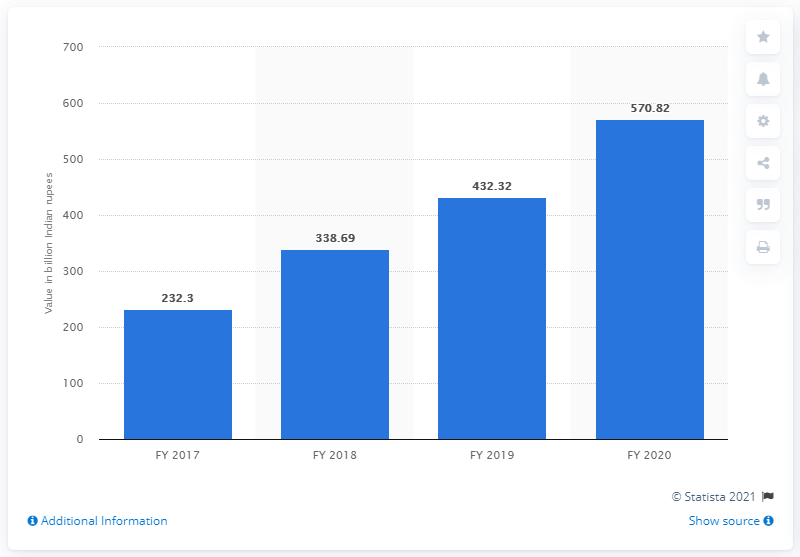Indicate a few pertinent items in this graphic. In the previous fiscal year, the value of Bandhan Bank deposits was 232.3... In the fiscal year 2020, the value of Bandhan Bank deposits in India was 570.82. 